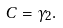Convert formula to latex. <formula><loc_0><loc_0><loc_500><loc_500>C = \gamma _ { 2 } .</formula> 